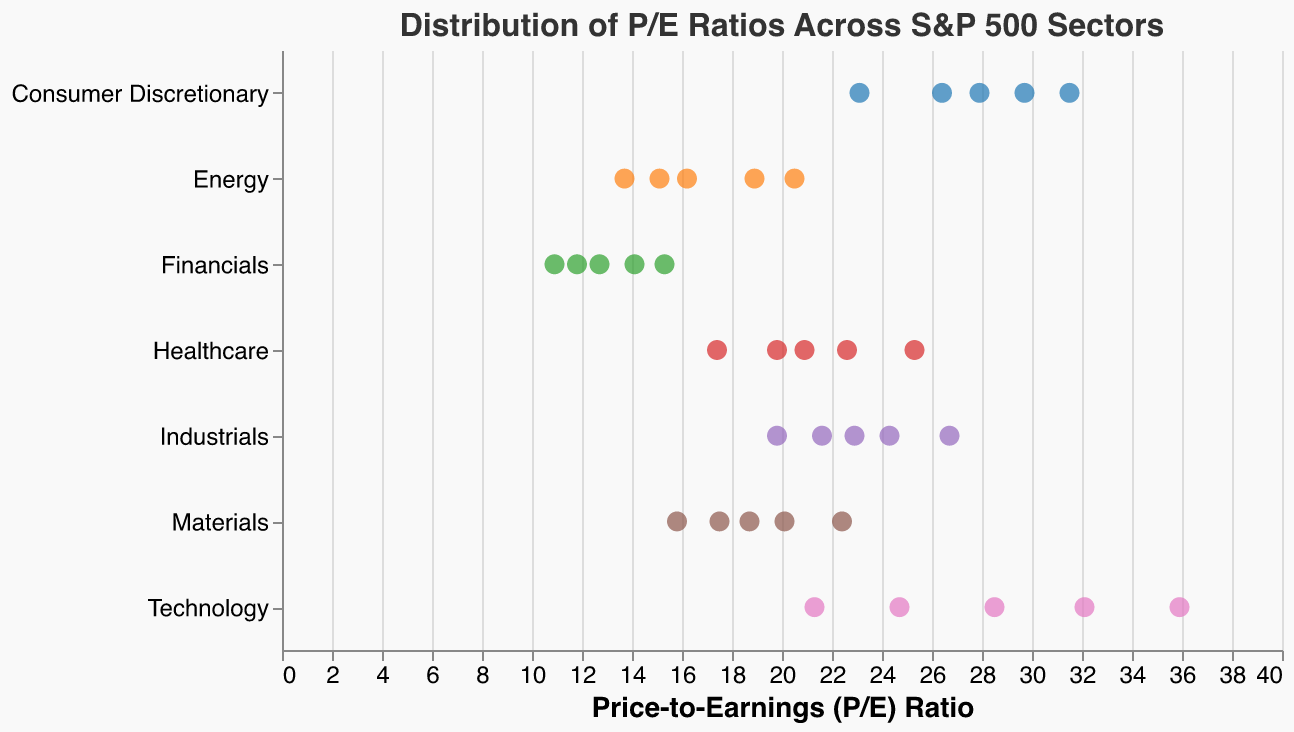What is the maximum P/E ratio in the Technology sector? The highest "P/E Ratio" recorded for the "Technology" sector can be observed from the plot. It is 35.9.
Answer: 35.9 What is the average P/E ratio for the Financials sector? Sum the P/E ratios of the Financials sector (12.7 + 15.3 + 10.9 + 14.1 + 11.8) and divide by the number of data points (5). The average is (12.7 + 15.3 + 10.9 + 14.1 + 11.8) / 5 = 12.96.
Answer: 12.96 Which sector has the most scattered data points for P/E ratios? Compare the spread of P/E Ratios across different sectors in the plot. The Technology sector has the widest range, from 21.3 to 35.9, indicating the most scatter.
Answer: Technology Which sector has the lowest P/E ratio value, and what is it? Identify the lowest P/E Ratio on the plot and look at the corresponding sector. The lowest value is 10.9 in the Financials sector.
Answer: Financials, 10.9 How does the median P/E ratio of the Consumer Discretionary sector compare to the Industrial sector? Organize the P/E Ratios of both sectors and find the middle value for a comparison. Consumer Discretionary: (23.1, 26.4, 27.9, 29.7, 31.5) median is 27.9. Industrials: (19.8, 21.6, 22.9, 24.3, 26.7) median is 22.9. The median P/E of Consumer Discretionary is higher than Industrials.
Answer: Consumer Discretionary > Industrials What is the spread of P/E ratios in the Energy sector? Identify the lowest and highest values in the Energy sector from the plot, the spread is the difference between them. The range is from 13.7 to 20.5, so the spread is 20.5 - 13.7 = 6.8.
Answer: 6.8 How many sectors have a P/E ratio above 20? Count the number of sectors where at least one P/E ratio data point exceeds 20 in the plot. Technology, Healthcare, Consumer Discretionary, Industrials, and Materials sectors all have P/E ratios above 20, making a total of 5 sectors.
Answer: 5 What can you infer about the sector with the most consistent P/E ratios? Look for the sector with the smallest range (spread) of P/E ratios in the plot. The Financials sector has the smallest spread (from 10.9 to 15.3), indicating consistent P/E ratios.
Answer: Financials Which sector has the highest minimum P/E ratio? From the plot, identify the smallest P/E ratio for each sector, and then find the sector with the highest of these minimum values. The Technology sector has the highest minimum P/E ratio at 21.3.
Answer: Technology 